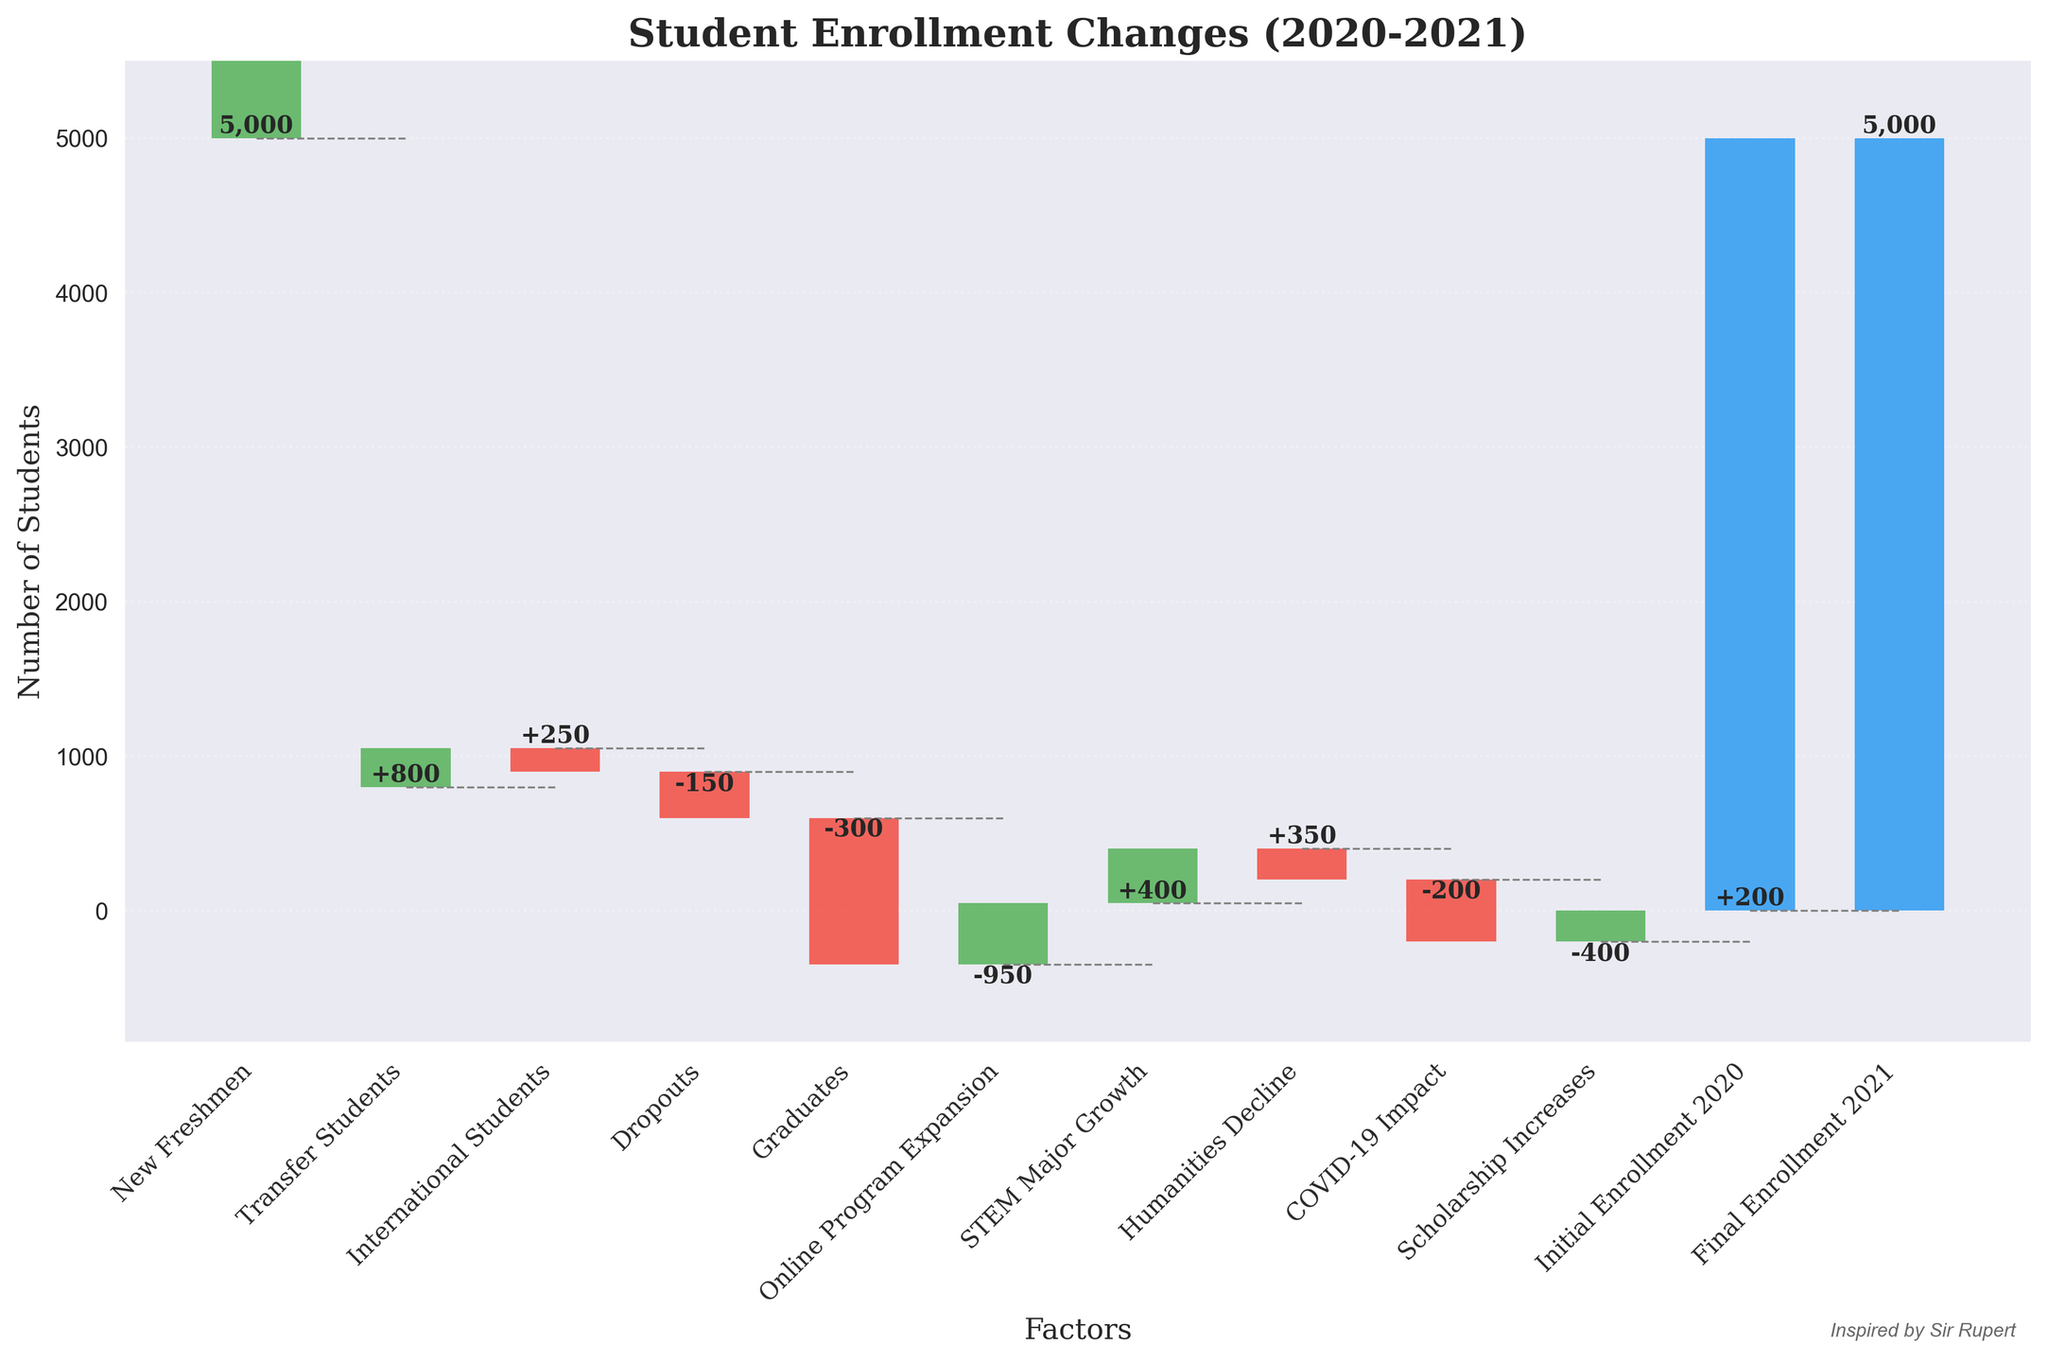How many categories contributed to the increase or decrease in student enrollment? To determine the number of categories, we can simply count the list of contributing factors in the chart. Excluding the initial and final enrollments, we count the remaining categories.
Answer: 10 What was the most significant factor that contributed to an increase in enrollment? By examining the upward and downward changes in the chart, we can identify the largest positive change. Here, "New Freshmen" has the highest positive value of +800.
Answer: New Freshmen What was the net change in student enrollment due to "Dropouts" and "Graduates"? The net change is calculated by adding the values of Dropouts (-300) and Graduates (-950). The sum of these changes is -1250.
Answer: -1250 Which factor had the smallest negative impact on enrollment? By looking at the decreasing categories in the chart, we can see that “International Students” caused the smallest decrease of -150.
Answer: International Students If we exclude the "COVID-19 Impact" factor, what would be the final enrollment? First, identify the cumulative value just before the "COVID-19 Impact" by summing the previous changes: 5000 + 800 + 250 - 150 - 300 - 950 + 400 + 350 - 200 = 5200. Without COVID-19 Impact, final would be 5200 + 200 = 5400.
Answer: 5400 How does the impact of "STEM Major Growth" compare to "Humanities Decline"? By comparing the values of STEM Major Growth (+350) and Humanities Decline (-200), you can see that STEM Major Growth had a larger impact in absolute terms (+350 vs. -200).
Answer: STEM Major Growth had a larger impact What is the net effect on enrollment of all positive change factors combined? Add up all the positive impact factors: New Freshmen (+800), Transfer Students (+250), Online Program Expansion (+400), STEM Major Growth (+350), and Scholarship Increases (+200): 800 + 250 + 400 + 350 + 200 = 2000.
Answer: 2000 Did the enrollment ultimately increase, decrease, or remain the same from 2020 to 2021? The final enrollment value (5000) is equal to the initial enrollment value (5000), indicating that the enrollment remained the same.
Answer: Remained the same What was the overall effect of the "COVID-19 Impact" on the final enrollment number? The "COVID-19 Impact" had a significant negative effect of -400 students on the final enrollment.
Answer: -400 What is the cumulative enrollment just before the "Scholarship Increases" factor? Sum the initial enrollment and all preceding changes before "Scholarship Increases": 5000 + 800 + 250 - 150 - 300 - 950 + 400 + 350 - 200 - 400 = 4800.
Answer: 4800 